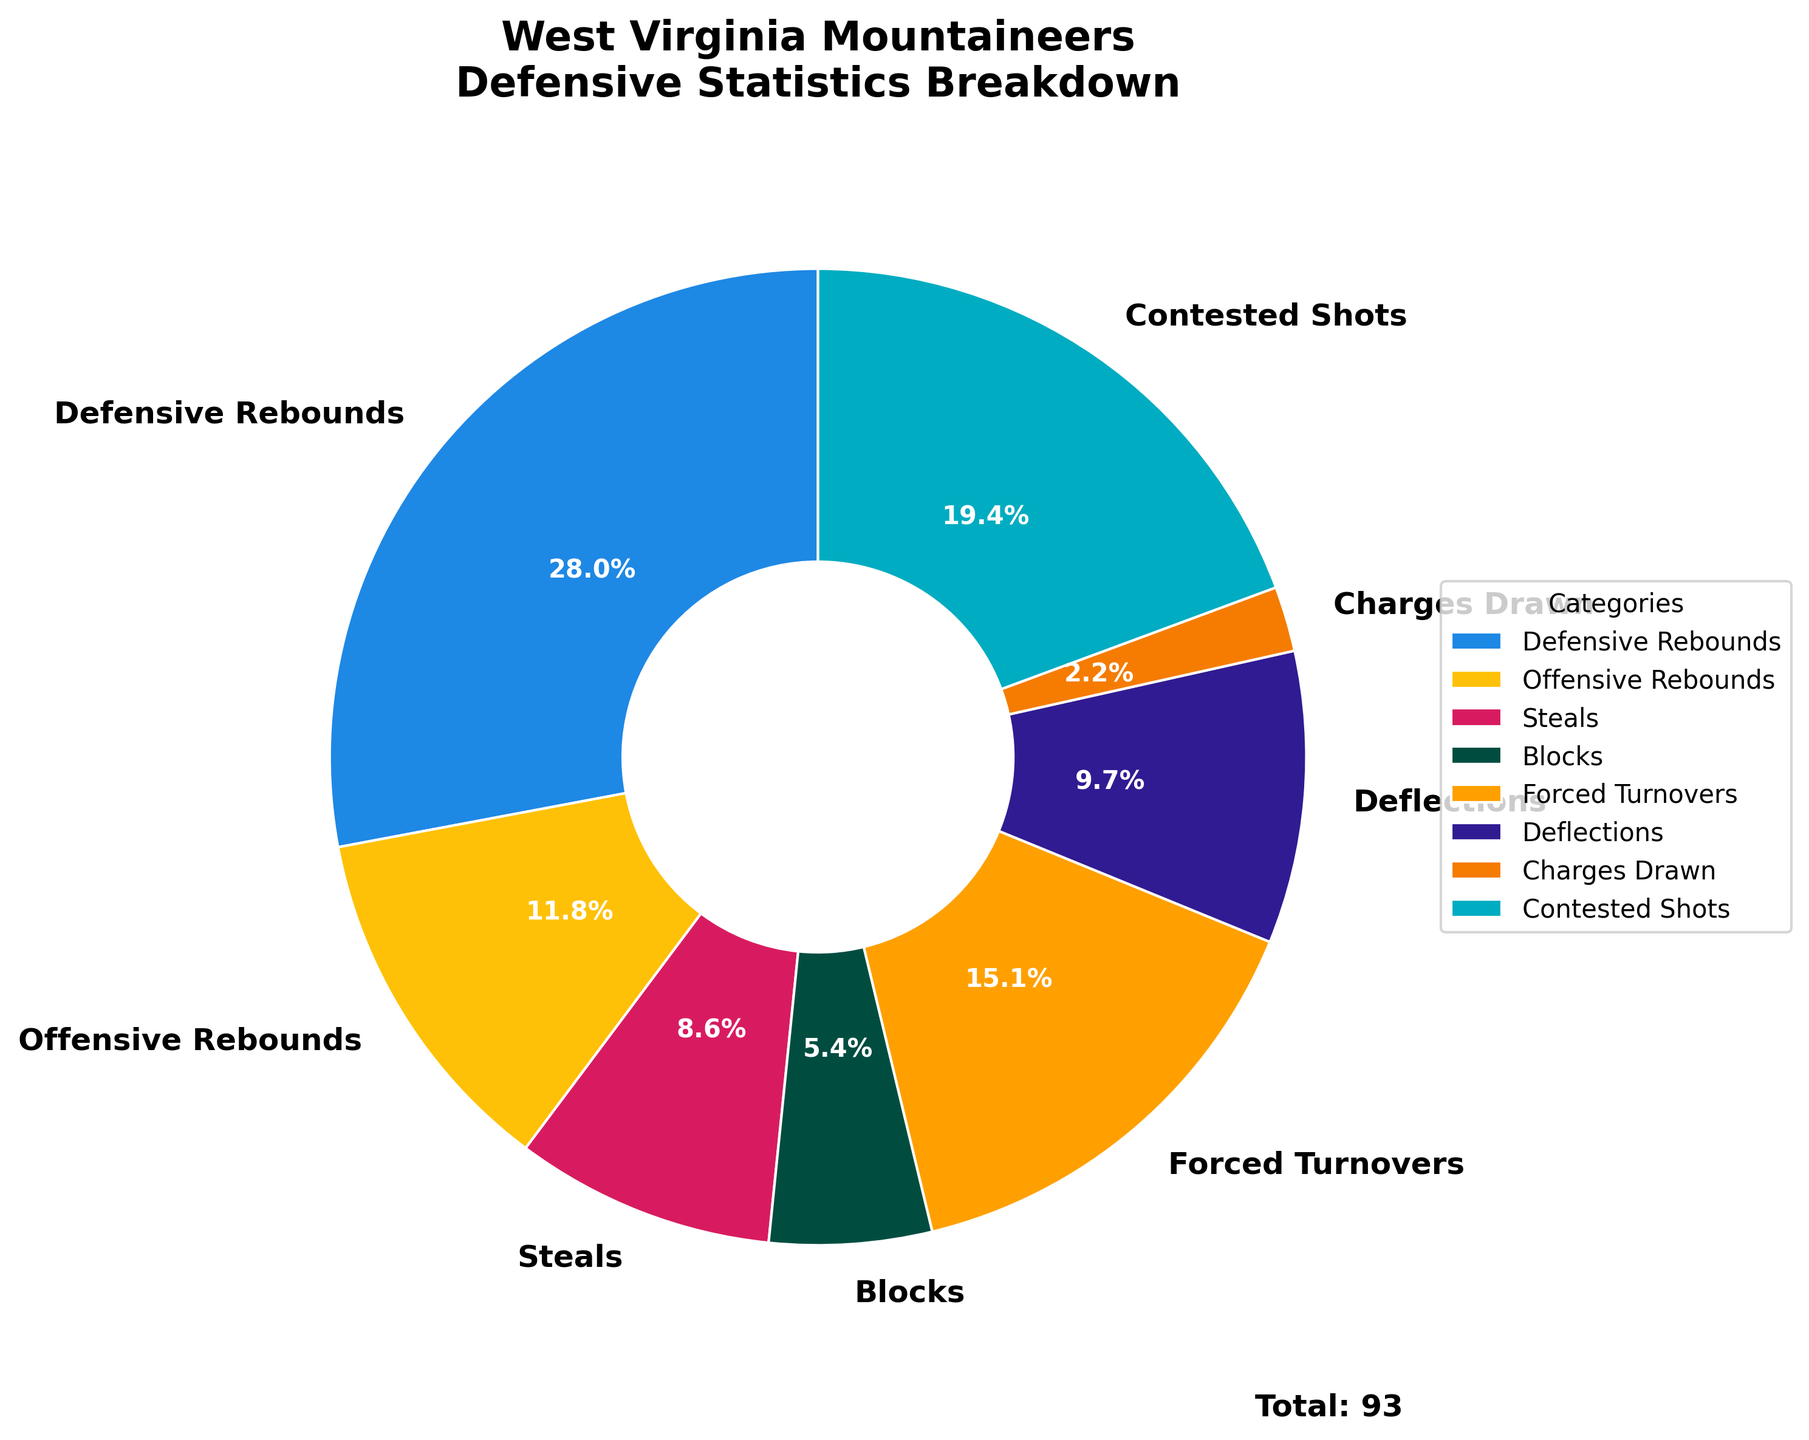Which category has the highest value? The pie chart indicates the respective values for each category. By observing the sections, the one labeled with the highest percentage or largest slice is easily identifiable. The largest section is for Defensive Rebounds.
Answer: Defensive Rebounds How many total rebounds does the team have? To find the total number of rebounds, sum up the values for Offensive Rebounds and Defensive Rebounds. From the data: 26 (Defensive Rebounds) + 11 (Offensive Rebounds) = 37.
Answer: 37 Which category has the smallest contribution to the total? The smallest section of the pie chart corresponds to the category with the smallest percentage. The slice labeled Charges Drawn is the smallest.
Answer: Charges Drawn What percentage of the defensive statistics is made up of blocks and steals combined? First, sum the values for Blocks and Steals: 5 (Blocks) + 8 (Steals) = 13. Then, determine the total sum of all categories, which is 93. Finally, calculate the percentage: (13/93) * 100 ≈ 13.98%.
Answer: ~14% What's the difference between forced turnovers and deflections? Forced Turnovers and Deflections are both identified on the pie chart along with their respective values. The difference is found by subtraction: 14 (Forced Turnovers) - 9 (Deflections) = 5.
Answer: 5 Among contested shots, charges drawn, and deflections, which has the highest value? By comparing the sizes of the sections corresponding to Contested Shots, Charges Drawn, and Deflections in the pie chart, it is clear that the largest section is for Contested Shots.
Answer: Contested Shots What fraction of the total defensive statistics does forced turnovers represent? To find the fraction, place the value for Forced Turnovers over the sum of all categories: 14/93. Simplify the fraction if necessary.
Answer: 14/93 How do the values of steals and blocks compare to each other? The values for Steals and Blocks can be directly compared from the pie chart. Steals have a higher value (8) compared to Blocks (5).
Answer: Steals > Blocks What percentage of the total is made up by contested shots? To find the percentage, divide the value for Contested Shots by the total sum: (18/93) * 100 ≈ 19.35%.
Answer: ~19% 